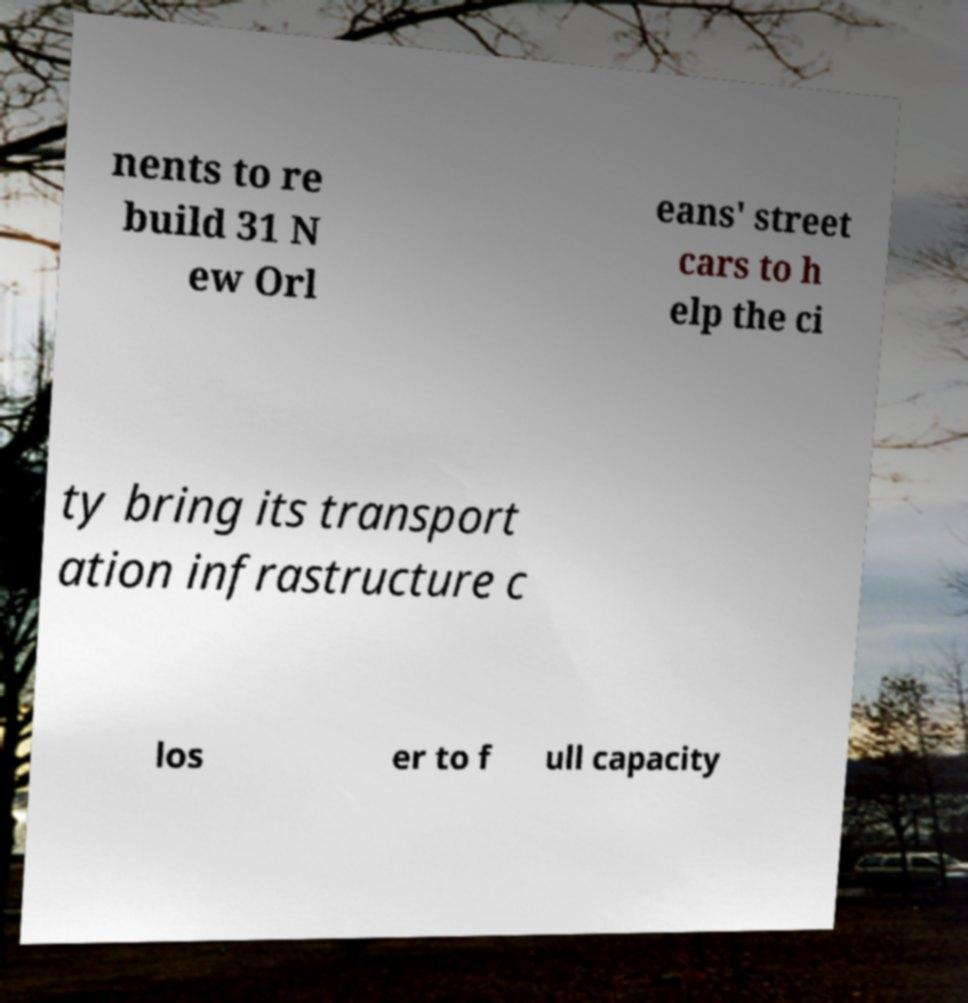Please read and relay the text visible in this image. What does it say? nents to re build 31 N ew Orl eans' street cars to h elp the ci ty bring its transport ation infrastructure c los er to f ull capacity 